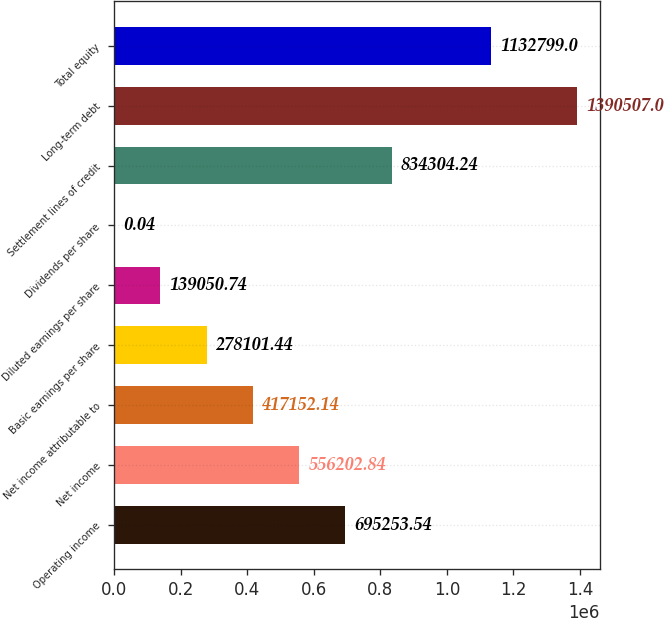<chart> <loc_0><loc_0><loc_500><loc_500><bar_chart><fcel>Operating income<fcel>Net income<fcel>Net income attributable to<fcel>Basic earnings per share<fcel>Diluted earnings per share<fcel>Dividends per share<fcel>Settlement lines of credit<fcel>Long-term debt<fcel>Total equity<nl><fcel>695254<fcel>556203<fcel>417152<fcel>278101<fcel>139051<fcel>0.04<fcel>834304<fcel>1.39051e+06<fcel>1.1328e+06<nl></chart> 